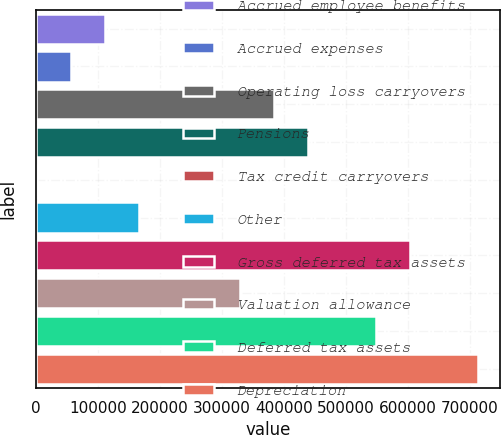<chart> <loc_0><loc_0><loc_500><loc_500><bar_chart><fcel>Accrued employee benefits<fcel>Accrued expenses<fcel>Operating loss carryovers<fcel>Pensions<fcel>Tax credit carryovers<fcel>Other<fcel>Gross deferred tax assets<fcel>Valuation allowance<fcel>Deferred tax assets<fcel>Depreciation<nl><fcel>110595<fcel>55811.9<fcel>384509<fcel>439292<fcel>1029<fcel>165378<fcel>603641<fcel>329726<fcel>548858<fcel>713207<nl></chart> 